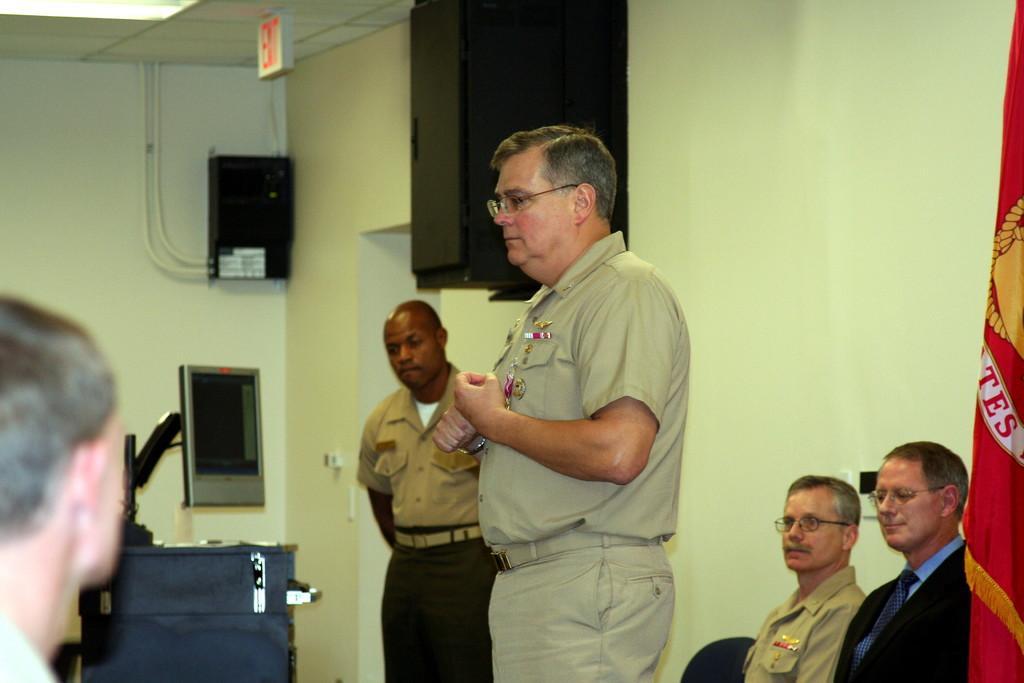In one or two sentences, can you explain what this image depicts? There are people, two people sitting on chairs and these two people standing. We can see objects on the table. We can see speaker and devices on the wall. At the top we can see ceiling light and board. On the right side of the image we can see flag. 